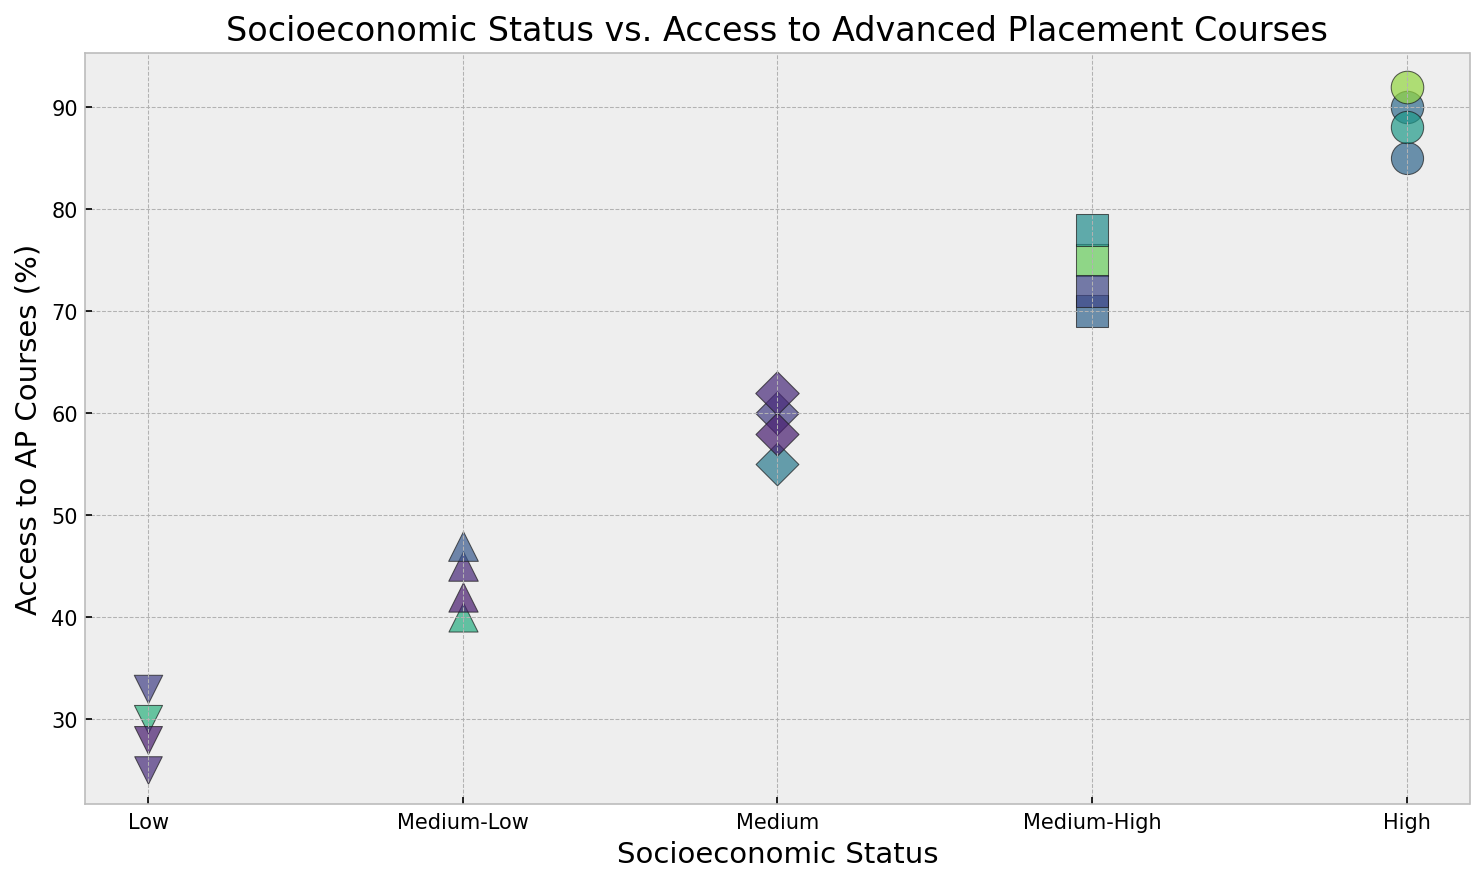What is the general trend between Socioeconomic Status and Access to AP Courses? By looking at the scatter plot, we see that as the Socioeconomic Status increases from 'Low' to 'High', the Access to AP Courses percentage generally increases.
Answer: Higher Socioeconomic Status generally leads to higher Access to AP Courses Which data point represents the highest Access to AP Courses, and what is its Socioeconomic Status? The data point representing the highest Access to AP Courses is at 92%, which corresponds to 'High' Socioeconomic Status.
Answer: High Compare the average Access to AP Courses percentages for 'Medium' and 'Medium-High' Socioeconomic Status groups. For 'Medium': (60 + 55 + 58 + 62)/4 = 235/4 = 58.75. For 'Medium-High': (75 + 70 + 72 + 78)/4 = 295/4 = 73.75. The average for 'Medium-High' is higher than for 'Medium'.
Answer: Medium-High has a higher average How does the Access to AP Courses for 'Low' Socioeconomic Status compare to the 'High' Socioeconomic Status? 'Low' Socioeconomic Status ranges between 25% to 33%, while 'High' Socioeconomic Status ranges between 85% to 92%. The 'High' group consistently has more Access to AP Courses.
Answer: High has significantly more access Identify a 'Medium-Low' Socioeconomic Status data point and describe the color and size of its corresponding marker. For instance, the marker at 'Medium-Low' with 45% Access to AP Courses is visually represented with a specific shade of color and size on the plot. The color would be one of the generated colors, and the size scaling is a bit larger than other points due to the 45% value.
Answer: Specific shade and larger size What is the difference in percentage of Access to AP Courses between 'Medium' and 'Low' Socioeconomic Status groups? The 'Medium' group has 60 - 55 - 58 - 62% and the 'Low' group has 30 - 25 - 28 - 33%. Average for 'Medium': (60 + 55 + 58 + 62)/4 = 58.75. For 'Low': (30 + 25 + 28 + 33)/4 = 29. The difference is 58.75 - 29 = 29.75%.
Answer: 29.75% Is there a clear correlation between the size of the markers and the Access to AP Courses percentage? Observing the scatter plot, larger markers mostly correspond to higher percentages of Access to AP Courses, indicating a positive correlation between marker size and Access to AP Courses percentage.
Answer: Yes Which Socioeconomic Status group shows the greatest variability in Access to AP Courses? By inspecting the range of Access to AP Courses percentages within each group, the 'Medium' group shows percentages from 55% to 62%, indicating a spread of 7 percentage points. Other groups have a narrower range.
Answer: Medium From the plot, identify one characteristic that differentiates the 'High' Socioeconomic Status group's markers from the rest. The 'High' Socioeconomic Status group has the highest percentages of Access to AP Courses and the largest marker sizes. Visually, it's particularly distinguished by these larger markers.
Answer: Largest marker sizes 